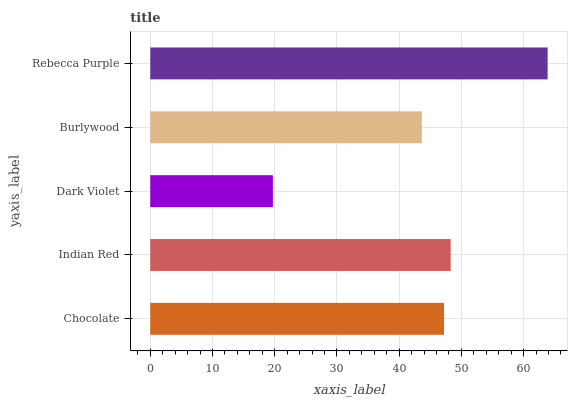Is Dark Violet the minimum?
Answer yes or no. Yes. Is Rebecca Purple the maximum?
Answer yes or no. Yes. Is Indian Red the minimum?
Answer yes or no. No. Is Indian Red the maximum?
Answer yes or no. No. Is Indian Red greater than Chocolate?
Answer yes or no. Yes. Is Chocolate less than Indian Red?
Answer yes or no. Yes. Is Chocolate greater than Indian Red?
Answer yes or no. No. Is Indian Red less than Chocolate?
Answer yes or no. No. Is Chocolate the high median?
Answer yes or no. Yes. Is Chocolate the low median?
Answer yes or no. Yes. Is Dark Violet the high median?
Answer yes or no. No. Is Rebecca Purple the low median?
Answer yes or no. No. 